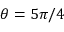Convert formula to latex. <formula><loc_0><loc_0><loc_500><loc_500>\theta = 5 \pi / 4</formula> 